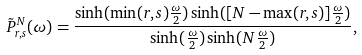Convert formula to latex. <formula><loc_0><loc_0><loc_500><loc_500>\tilde { P } _ { r , s } ^ { N } ( \omega ) = \frac { \sinh ( \min ( r , s ) \frac { \omega } { 2 } ) \sinh ( [ N - \max ( r , s ) ] \frac { \omega } { 2 } ) } { \sinh ( \frac { \omega } { 2 } ) \sinh ( N \frac { \omega } { 2 } ) } ,</formula> 